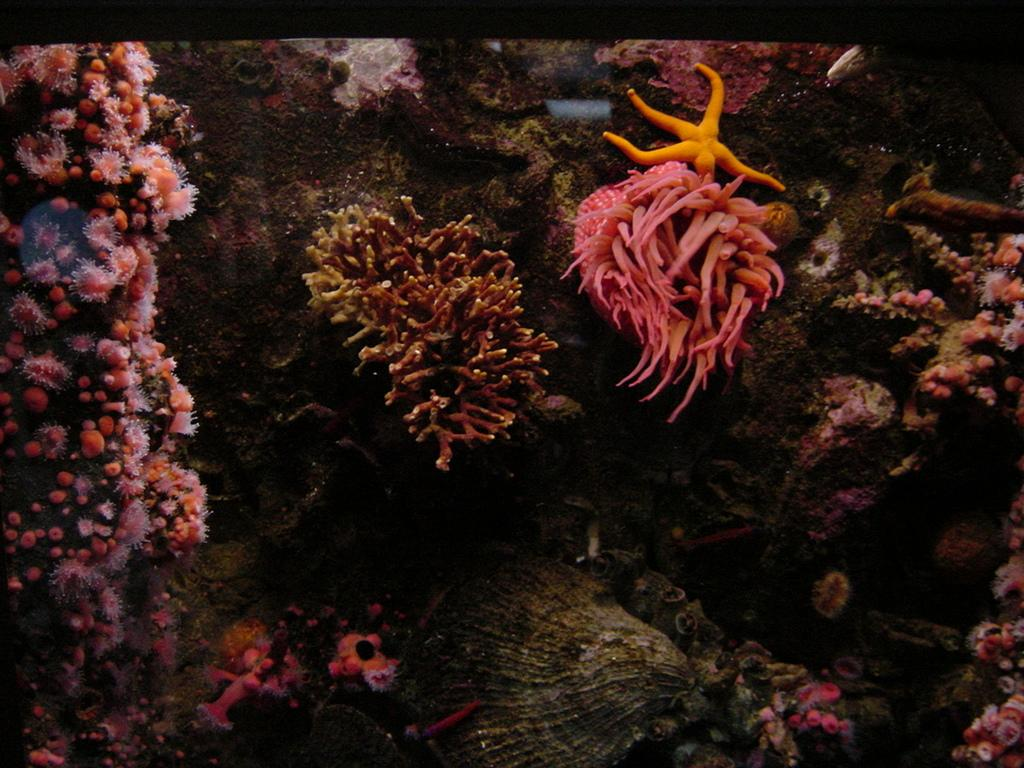What type of environment is depicted in the image? The image shows organisms in the water. Can you identify any specific organisms in the image? Yes, there is a starfish visible at the top of the image. What type of lace can be seen in the image? There is no lace present in the image; it features organisms in the water. What scent is associated with the image? The image does not have a scent; it is a visual representation of organisms in the water. 